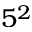Convert formula to latex. <formula><loc_0><loc_0><loc_500><loc_500>5 ^ { 2 }</formula> 